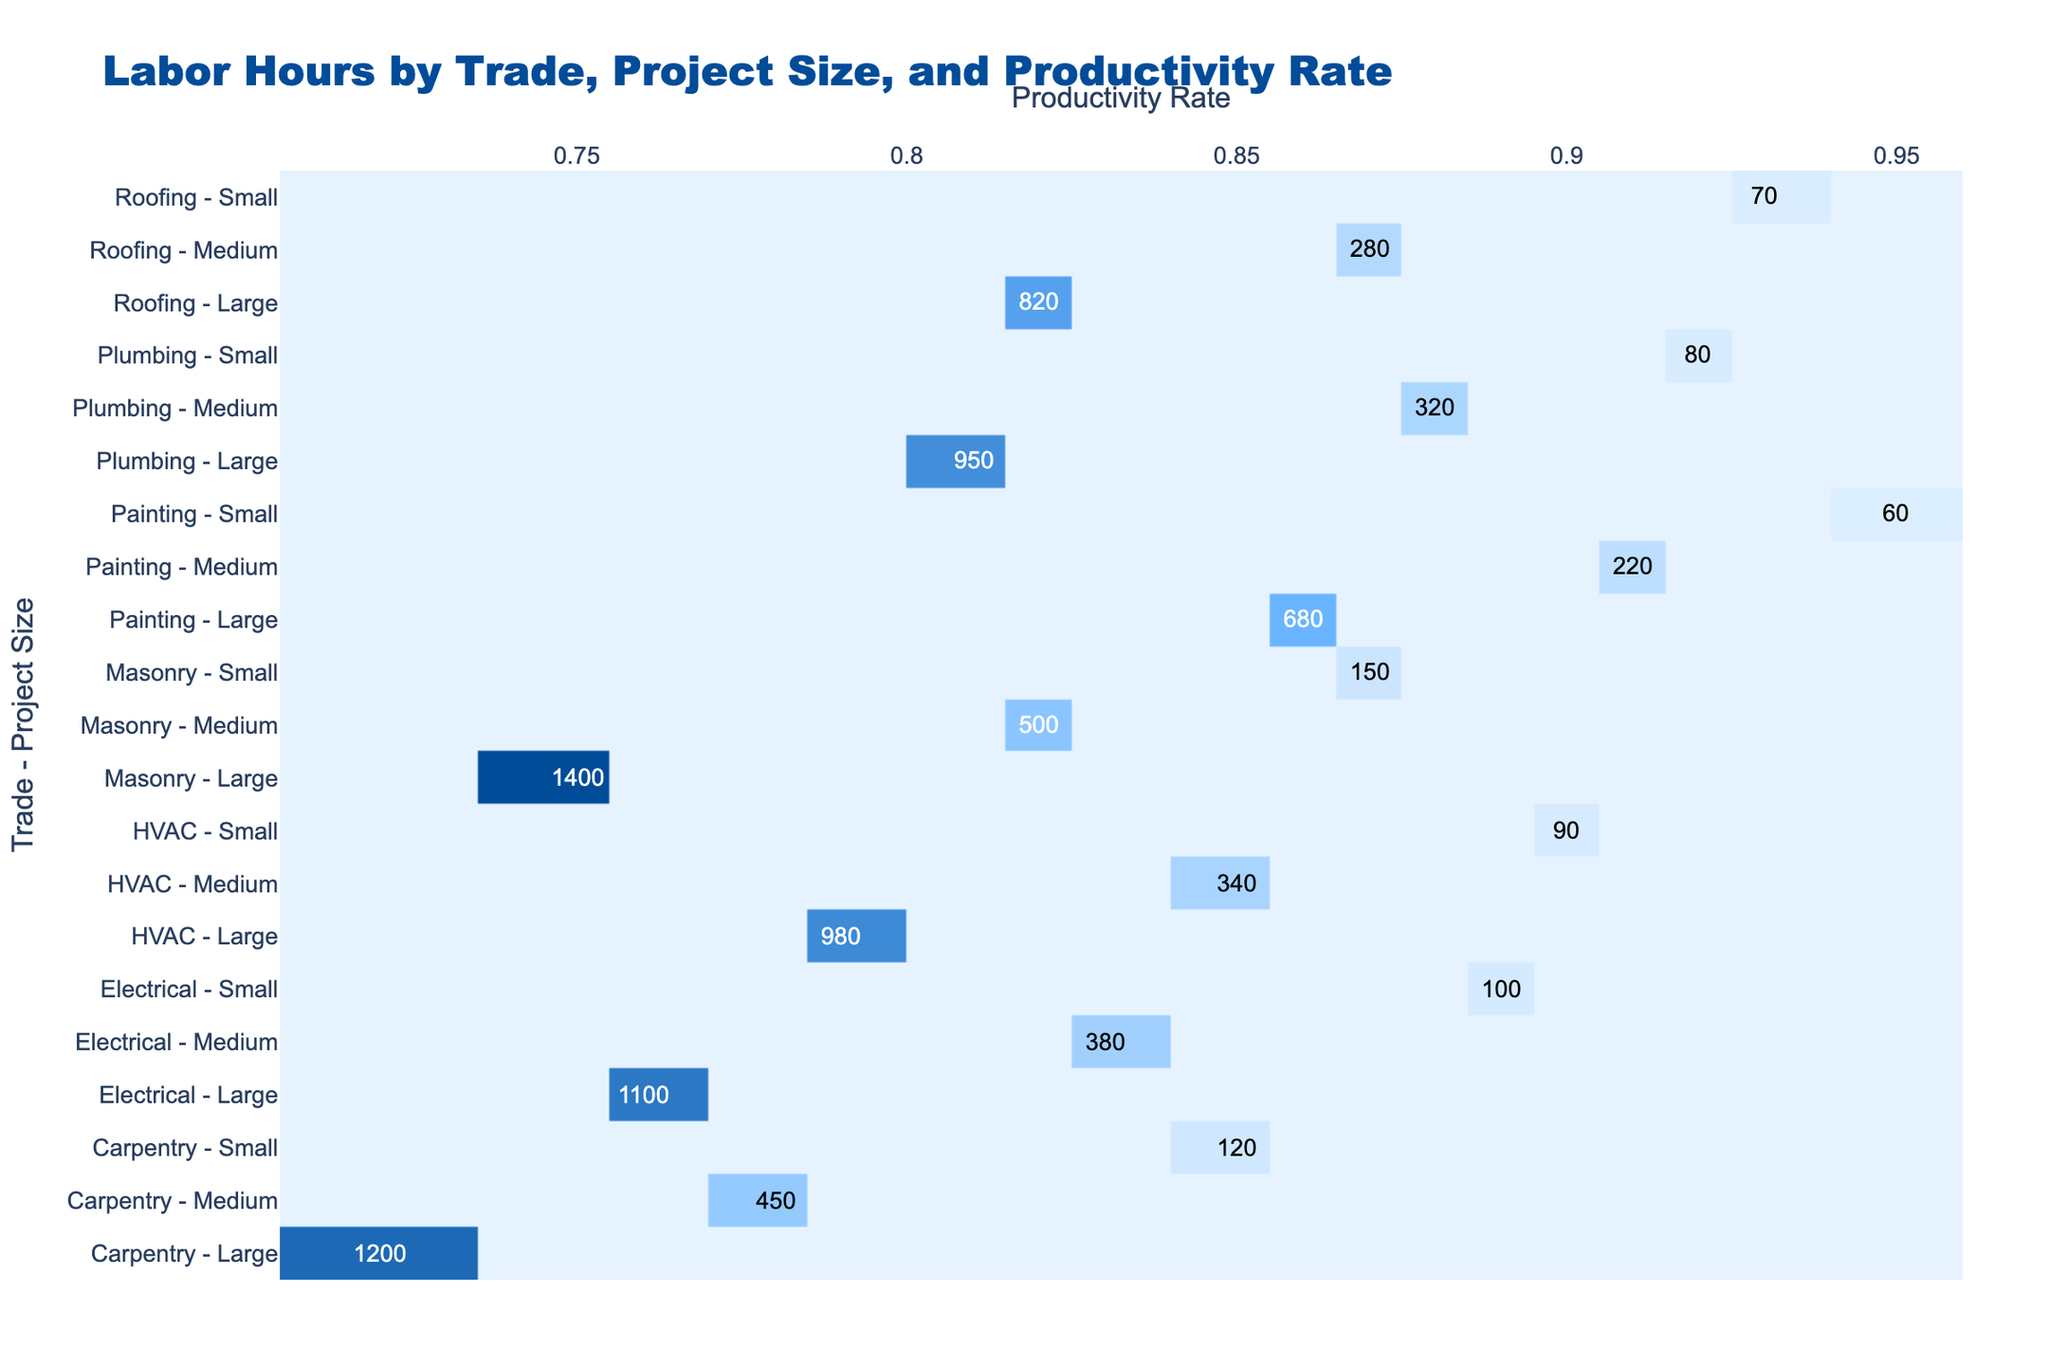What is the total labor hours for Carpentry in Medium projects? There is one entry for Carpentry in Medium projects, which shows 450 labor hours. Therefore, the total is simply 450.
Answer: 450 How many labor hours are required for Plumbing in Large projects? There is one entry for Plumbing in Large projects, which records 950 labor hours. Thus, the answer is straightforwardly 950.
Answer: 950 Is the productivity rate for Electrical in Medium projects greater than 0.80? The productivity rate for Electrical in Medium projects is reported as 0.83, which is indeed greater than 0.80.
Answer: Yes What are the total labor hours for Large projects across all trades? To find this, we sum the labor hours for all trades under Large projects: Carpentry (1200) + Plumbing (950) + Electrical (1100) + Masonry (1400) + Painting (680) + HVAC (980) + Roofing (820) = 5150.
Answer: 5150 Which trade has the highest labor hours for Small projects, and how many hours? Analyzing the Small projects, the following labor hours are recorded: Carpentry (120), Plumbing (80), Electrical (100), Masonry (150), Painting (60), HVAC (90), and Roofing (70). The highest is Masonry with 150 labor hours.
Answer: Masonry, 150 What is the average productivity rate for Medium projects across all trades? The productivity rates for Medium projects by trade are Carpentry (0.78), Plumbing (0.88), Electrical (0.83), Masonry (0.82), Painting (0.91), HVAC (0.85), and Roofing (0.87). To calculate the average, we sum these rates (0.78 + 0.88 + 0.83 + 0.82 + 0.91 + 0.85 + 0.87 = 6.04) and divide by the number of trades (7). The average is 6.04/7 ≈ 0.86.
Answer: 0.86 Did any trade in Large projects have a productivity rate below 0.80? Analyzing the productivity rates for Large projects, we find Carpentry (0.72), Plumbing (0.81), Electrical (0.76), Masonry (0.75), Painting (0.86), HVAC (0.79), and Roofing (0.82). The trades Carpentry, Electrical, and HVAC have rates below 0.80.
Answer: Yes Which trade has the lowest productivity rate among all Medium projects? The productivity rates for Medium projects are as follows: Carpentry (0.78), Plumbing (0.88), Electrical (0.83), Masonry (0.82), Painting (0.91), HVAC (0.85), Roofing (0.87). The lowest rate is Carpentry with 0.78.
Answer: Carpentry, 0.78 